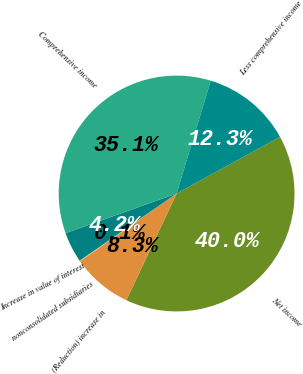<chart> <loc_0><loc_0><loc_500><loc_500><pie_chart><fcel>Net income<fcel>(Reduction) increase in<fcel>nonconsolidated subsidiaries<fcel>Increase in value of interest<fcel>Comprehensive income<fcel>Less comprehensive income<nl><fcel>39.99%<fcel>8.26%<fcel>0.1%<fcel>4.18%<fcel>35.13%<fcel>12.34%<nl></chart> 